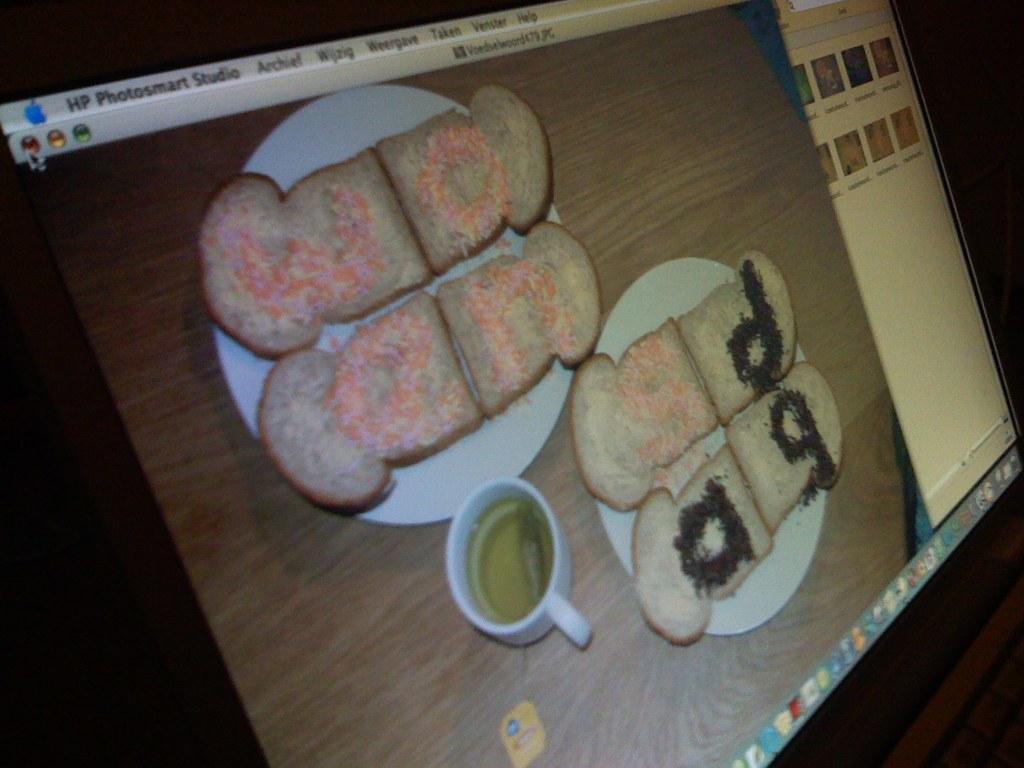Please provide a concise description of this image. In this image there is a monitor screen. 